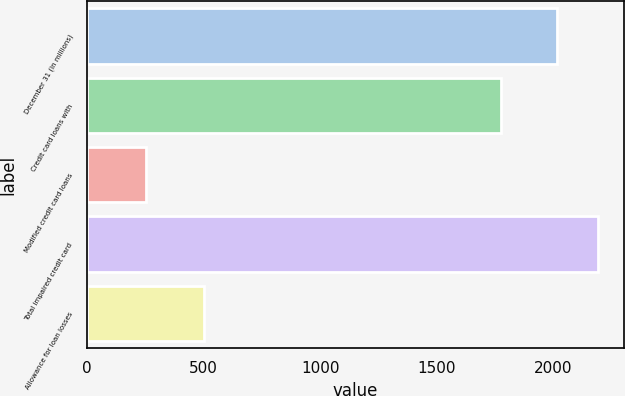<chart> <loc_0><loc_0><loc_500><loc_500><bar_chart><fcel>December 31 (in millions)<fcel>Credit card loans with<fcel>Modified credit card loans<fcel>Total impaired credit card<fcel>Allowance for loan losses<nl><fcel>2014<fcel>1775<fcel>254<fcel>2191.5<fcel>500<nl></chart> 